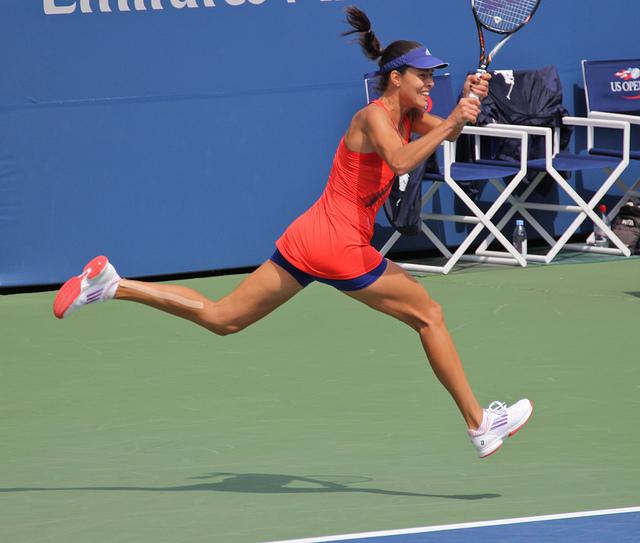What color is the sole of the athletes shoe?
Be succinct. Orange. What game is she playing?
Be succinct. Tennis. What color is the wall in the back?
Concise answer only. Blue. How much time is left?
Keep it brief. 0. 